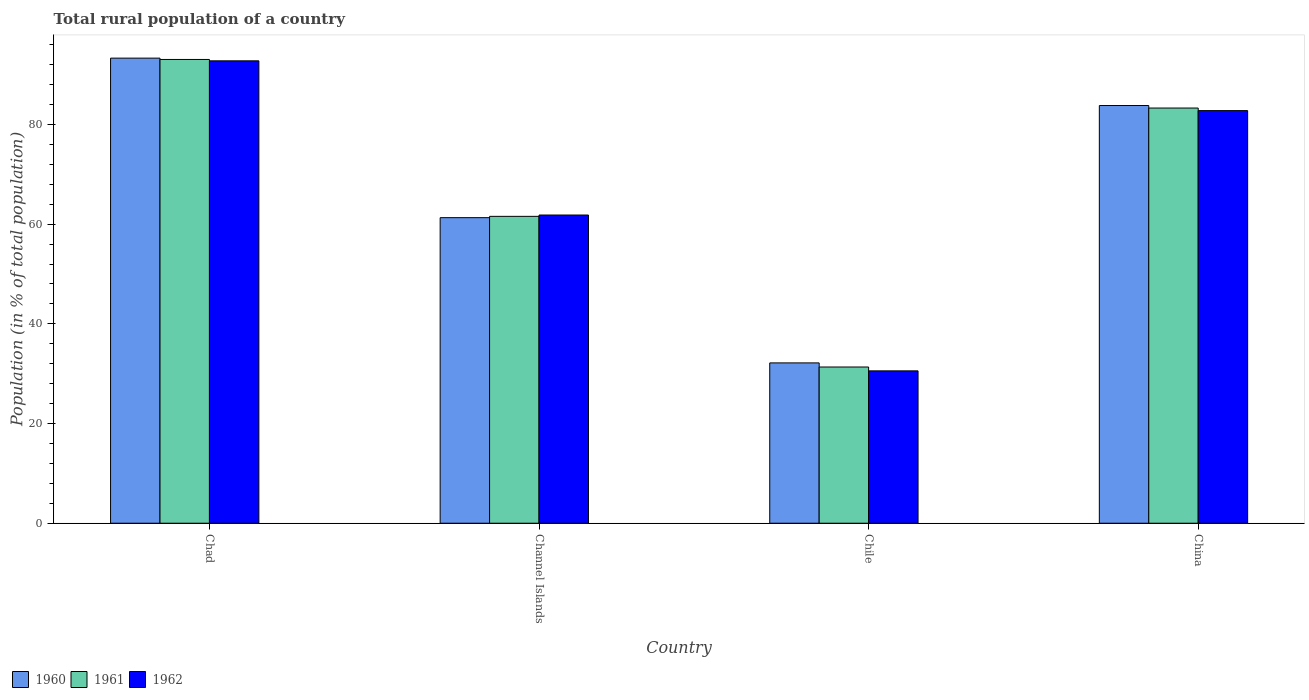How many different coloured bars are there?
Provide a succinct answer. 3. Are the number of bars per tick equal to the number of legend labels?
Provide a succinct answer. Yes. Are the number of bars on each tick of the X-axis equal?
Provide a short and direct response. Yes. How many bars are there on the 1st tick from the right?
Your response must be concise. 3. What is the label of the 2nd group of bars from the left?
Your response must be concise. Channel Islands. In how many cases, is the number of bars for a given country not equal to the number of legend labels?
Ensure brevity in your answer.  0. What is the rural population in 1960 in Channel Islands?
Your response must be concise. 61.3. Across all countries, what is the maximum rural population in 1960?
Offer a terse response. 93.31. Across all countries, what is the minimum rural population in 1961?
Your response must be concise. 31.34. In which country was the rural population in 1960 maximum?
Ensure brevity in your answer.  Chad. In which country was the rural population in 1961 minimum?
Ensure brevity in your answer.  Chile. What is the total rural population in 1960 in the graph?
Give a very brief answer. 270.57. What is the difference between the rural population in 1962 in Chad and that in Chile?
Keep it short and to the point. 62.2. What is the difference between the rural population in 1962 in Chile and the rural population in 1961 in China?
Provide a short and direct response. -52.73. What is the average rural population in 1960 per country?
Your answer should be very brief. 67.64. What is the difference between the rural population of/in 1961 and rural population of/in 1962 in Chad?
Keep it short and to the point. 0.28. What is the ratio of the rural population in 1961 in Channel Islands to that in Chile?
Provide a short and direct response. 1.96. Is the rural population in 1960 in Chad less than that in Channel Islands?
Provide a short and direct response. No. What is the difference between the highest and the second highest rural population in 1960?
Keep it short and to the point. -22.5. What is the difference between the highest and the lowest rural population in 1960?
Your answer should be very brief. 61.14. In how many countries, is the rural population in 1960 greater than the average rural population in 1960 taken over all countries?
Your answer should be very brief. 2. Is the sum of the rural population in 1962 in Channel Islands and China greater than the maximum rural population in 1960 across all countries?
Your response must be concise. Yes. What does the 3rd bar from the left in Chad represents?
Offer a terse response. 1962. What does the 2nd bar from the right in Chile represents?
Give a very brief answer. 1961. Is it the case that in every country, the sum of the rural population in 1961 and rural population in 1962 is greater than the rural population in 1960?
Provide a short and direct response. Yes. Does the graph contain grids?
Your response must be concise. No. Where does the legend appear in the graph?
Make the answer very short. Bottom left. How are the legend labels stacked?
Ensure brevity in your answer.  Horizontal. What is the title of the graph?
Make the answer very short. Total rural population of a country. What is the label or title of the Y-axis?
Give a very brief answer. Population (in % of total population). What is the Population (in % of total population) in 1960 in Chad?
Your answer should be compact. 93.31. What is the Population (in % of total population) of 1961 in Chad?
Keep it short and to the point. 93.04. What is the Population (in % of total population) of 1962 in Chad?
Offer a terse response. 92.76. What is the Population (in % of total population) in 1960 in Channel Islands?
Offer a very short reply. 61.3. What is the Population (in % of total population) of 1961 in Channel Islands?
Your answer should be very brief. 61.56. What is the Population (in % of total population) of 1962 in Channel Islands?
Your answer should be compact. 61.83. What is the Population (in % of total population) in 1960 in Chile?
Ensure brevity in your answer.  32.16. What is the Population (in % of total population) in 1961 in Chile?
Provide a short and direct response. 31.34. What is the Population (in % of total population) of 1962 in Chile?
Your answer should be compact. 30.57. What is the Population (in % of total population) in 1960 in China?
Ensure brevity in your answer.  83.8. What is the Population (in % of total population) of 1961 in China?
Provide a short and direct response. 83.29. What is the Population (in % of total population) in 1962 in China?
Give a very brief answer. 82.77. Across all countries, what is the maximum Population (in % of total population) of 1960?
Ensure brevity in your answer.  93.31. Across all countries, what is the maximum Population (in % of total population) of 1961?
Give a very brief answer. 93.04. Across all countries, what is the maximum Population (in % of total population) in 1962?
Ensure brevity in your answer.  92.76. Across all countries, what is the minimum Population (in % of total population) of 1960?
Offer a very short reply. 32.16. Across all countries, what is the minimum Population (in % of total population) in 1961?
Keep it short and to the point. 31.34. Across all countries, what is the minimum Population (in % of total population) in 1962?
Give a very brief answer. 30.57. What is the total Population (in % of total population) of 1960 in the graph?
Offer a very short reply. 270.57. What is the total Population (in % of total population) of 1961 in the graph?
Ensure brevity in your answer.  269.23. What is the total Population (in % of total population) in 1962 in the graph?
Offer a terse response. 267.93. What is the difference between the Population (in % of total population) of 1960 in Chad and that in Channel Islands?
Provide a short and direct response. 32.01. What is the difference between the Population (in % of total population) in 1961 in Chad and that in Channel Islands?
Ensure brevity in your answer.  31.47. What is the difference between the Population (in % of total population) of 1962 in Chad and that in Channel Islands?
Your response must be concise. 30.93. What is the difference between the Population (in % of total population) of 1960 in Chad and that in Chile?
Your response must be concise. 61.14. What is the difference between the Population (in % of total population) of 1961 in Chad and that in Chile?
Make the answer very short. 61.7. What is the difference between the Population (in % of total population) in 1962 in Chad and that in Chile?
Make the answer very short. 62.2. What is the difference between the Population (in % of total population) of 1960 in Chad and that in China?
Make the answer very short. 9.51. What is the difference between the Population (in % of total population) of 1961 in Chad and that in China?
Ensure brevity in your answer.  9.75. What is the difference between the Population (in % of total population) in 1962 in Chad and that in China?
Your answer should be very brief. 9.99. What is the difference between the Population (in % of total population) of 1960 in Channel Islands and that in Chile?
Provide a short and direct response. 29.14. What is the difference between the Population (in % of total population) of 1961 in Channel Islands and that in Chile?
Give a very brief answer. 30.22. What is the difference between the Population (in % of total population) in 1962 in Channel Islands and that in Chile?
Make the answer very short. 31.26. What is the difference between the Population (in % of total population) in 1960 in Channel Islands and that in China?
Your answer should be very brief. -22.5. What is the difference between the Population (in % of total population) of 1961 in Channel Islands and that in China?
Keep it short and to the point. -21.73. What is the difference between the Population (in % of total population) in 1962 in Channel Islands and that in China?
Your response must be concise. -20.95. What is the difference between the Population (in % of total population) of 1960 in Chile and that in China?
Offer a very short reply. -51.63. What is the difference between the Population (in % of total population) of 1961 in Chile and that in China?
Ensure brevity in your answer.  -51.95. What is the difference between the Population (in % of total population) of 1962 in Chile and that in China?
Keep it short and to the point. -52.21. What is the difference between the Population (in % of total population) of 1960 in Chad and the Population (in % of total population) of 1961 in Channel Islands?
Provide a short and direct response. 31.74. What is the difference between the Population (in % of total population) in 1960 in Chad and the Population (in % of total population) in 1962 in Channel Islands?
Keep it short and to the point. 31.48. What is the difference between the Population (in % of total population) of 1961 in Chad and the Population (in % of total population) of 1962 in Channel Islands?
Offer a very short reply. 31.21. What is the difference between the Population (in % of total population) in 1960 in Chad and the Population (in % of total population) in 1961 in Chile?
Your answer should be very brief. 61.97. What is the difference between the Population (in % of total population) of 1960 in Chad and the Population (in % of total population) of 1962 in Chile?
Your answer should be very brief. 62.74. What is the difference between the Population (in % of total population) in 1961 in Chad and the Population (in % of total population) in 1962 in Chile?
Your answer should be compact. 62.47. What is the difference between the Population (in % of total population) of 1960 in Chad and the Population (in % of total population) of 1961 in China?
Provide a short and direct response. 10.01. What is the difference between the Population (in % of total population) in 1960 in Chad and the Population (in % of total population) in 1962 in China?
Your answer should be very brief. 10.53. What is the difference between the Population (in % of total population) of 1961 in Chad and the Population (in % of total population) of 1962 in China?
Your response must be concise. 10.26. What is the difference between the Population (in % of total population) of 1960 in Channel Islands and the Population (in % of total population) of 1961 in Chile?
Provide a short and direct response. 29.96. What is the difference between the Population (in % of total population) of 1960 in Channel Islands and the Population (in % of total population) of 1962 in Chile?
Provide a succinct answer. 30.73. What is the difference between the Population (in % of total population) of 1961 in Channel Islands and the Population (in % of total population) of 1962 in Chile?
Offer a very short reply. 31. What is the difference between the Population (in % of total population) of 1960 in Channel Islands and the Population (in % of total population) of 1961 in China?
Offer a terse response. -21.99. What is the difference between the Population (in % of total population) in 1960 in Channel Islands and the Population (in % of total population) in 1962 in China?
Provide a succinct answer. -21.47. What is the difference between the Population (in % of total population) of 1961 in Channel Islands and the Population (in % of total population) of 1962 in China?
Provide a short and direct response. -21.21. What is the difference between the Population (in % of total population) in 1960 in Chile and the Population (in % of total population) in 1961 in China?
Ensure brevity in your answer.  -51.13. What is the difference between the Population (in % of total population) in 1960 in Chile and the Population (in % of total population) in 1962 in China?
Give a very brief answer. -50.61. What is the difference between the Population (in % of total population) in 1961 in Chile and the Population (in % of total population) in 1962 in China?
Make the answer very short. -51.43. What is the average Population (in % of total population) of 1960 per country?
Ensure brevity in your answer.  67.64. What is the average Population (in % of total population) in 1961 per country?
Ensure brevity in your answer.  67.31. What is the average Population (in % of total population) of 1962 per country?
Keep it short and to the point. 66.98. What is the difference between the Population (in % of total population) in 1960 and Population (in % of total population) in 1961 in Chad?
Give a very brief answer. 0.27. What is the difference between the Population (in % of total population) of 1960 and Population (in % of total population) of 1962 in Chad?
Make the answer very short. 0.54. What is the difference between the Population (in % of total population) in 1961 and Population (in % of total population) in 1962 in Chad?
Offer a very short reply. 0.28. What is the difference between the Population (in % of total population) in 1960 and Population (in % of total population) in 1961 in Channel Islands?
Make the answer very short. -0.26. What is the difference between the Population (in % of total population) in 1960 and Population (in % of total population) in 1962 in Channel Islands?
Provide a succinct answer. -0.53. What is the difference between the Population (in % of total population) of 1961 and Population (in % of total population) of 1962 in Channel Islands?
Offer a terse response. -0.26. What is the difference between the Population (in % of total population) in 1960 and Population (in % of total population) in 1961 in Chile?
Your response must be concise. 0.82. What is the difference between the Population (in % of total population) of 1960 and Population (in % of total population) of 1962 in Chile?
Offer a very short reply. 1.6. What is the difference between the Population (in % of total population) in 1961 and Population (in % of total population) in 1962 in Chile?
Provide a short and direct response. 0.78. What is the difference between the Population (in % of total population) of 1960 and Population (in % of total population) of 1961 in China?
Offer a terse response. 0.51. What is the difference between the Population (in % of total population) in 1961 and Population (in % of total population) in 1962 in China?
Offer a terse response. 0.52. What is the ratio of the Population (in % of total population) in 1960 in Chad to that in Channel Islands?
Offer a very short reply. 1.52. What is the ratio of the Population (in % of total population) in 1961 in Chad to that in Channel Islands?
Make the answer very short. 1.51. What is the ratio of the Population (in % of total population) of 1962 in Chad to that in Channel Islands?
Offer a terse response. 1.5. What is the ratio of the Population (in % of total population) of 1960 in Chad to that in Chile?
Keep it short and to the point. 2.9. What is the ratio of the Population (in % of total population) of 1961 in Chad to that in Chile?
Your answer should be very brief. 2.97. What is the ratio of the Population (in % of total population) in 1962 in Chad to that in Chile?
Provide a short and direct response. 3.03. What is the ratio of the Population (in % of total population) of 1960 in Chad to that in China?
Ensure brevity in your answer.  1.11. What is the ratio of the Population (in % of total population) of 1961 in Chad to that in China?
Ensure brevity in your answer.  1.12. What is the ratio of the Population (in % of total population) in 1962 in Chad to that in China?
Keep it short and to the point. 1.12. What is the ratio of the Population (in % of total population) of 1960 in Channel Islands to that in Chile?
Keep it short and to the point. 1.91. What is the ratio of the Population (in % of total population) of 1961 in Channel Islands to that in Chile?
Keep it short and to the point. 1.96. What is the ratio of the Population (in % of total population) in 1962 in Channel Islands to that in Chile?
Offer a terse response. 2.02. What is the ratio of the Population (in % of total population) of 1960 in Channel Islands to that in China?
Your response must be concise. 0.73. What is the ratio of the Population (in % of total population) in 1961 in Channel Islands to that in China?
Offer a terse response. 0.74. What is the ratio of the Population (in % of total population) of 1962 in Channel Islands to that in China?
Provide a short and direct response. 0.75. What is the ratio of the Population (in % of total population) in 1960 in Chile to that in China?
Provide a succinct answer. 0.38. What is the ratio of the Population (in % of total population) in 1961 in Chile to that in China?
Keep it short and to the point. 0.38. What is the ratio of the Population (in % of total population) in 1962 in Chile to that in China?
Make the answer very short. 0.37. What is the difference between the highest and the second highest Population (in % of total population) in 1960?
Your answer should be very brief. 9.51. What is the difference between the highest and the second highest Population (in % of total population) in 1961?
Ensure brevity in your answer.  9.75. What is the difference between the highest and the second highest Population (in % of total population) of 1962?
Offer a very short reply. 9.99. What is the difference between the highest and the lowest Population (in % of total population) in 1960?
Your answer should be very brief. 61.14. What is the difference between the highest and the lowest Population (in % of total population) in 1961?
Provide a short and direct response. 61.7. What is the difference between the highest and the lowest Population (in % of total population) in 1962?
Give a very brief answer. 62.2. 